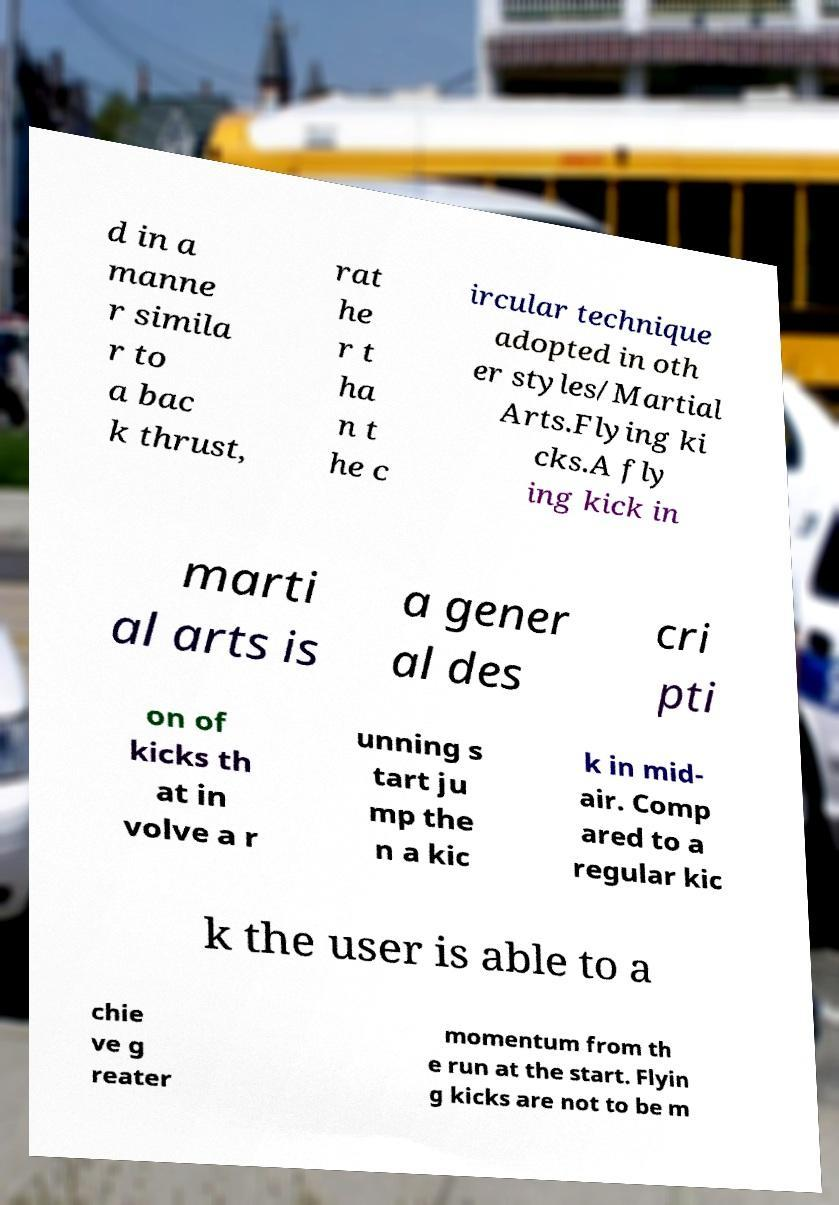Could you assist in decoding the text presented in this image and type it out clearly? d in a manne r simila r to a bac k thrust, rat he r t ha n t he c ircular technique adopted in oth er styles/Martial Arts.Flying ki cks.A fly ing kick in marti al arts is a gener al des cri pti on of kicks th at in volve a r unning s tart ju mp the n a kic k in mid- air. Comp ared to a regular kic k the user is able to a chie ve g reater momentum from th e run at the start. Flyin g kicks are not to be m 